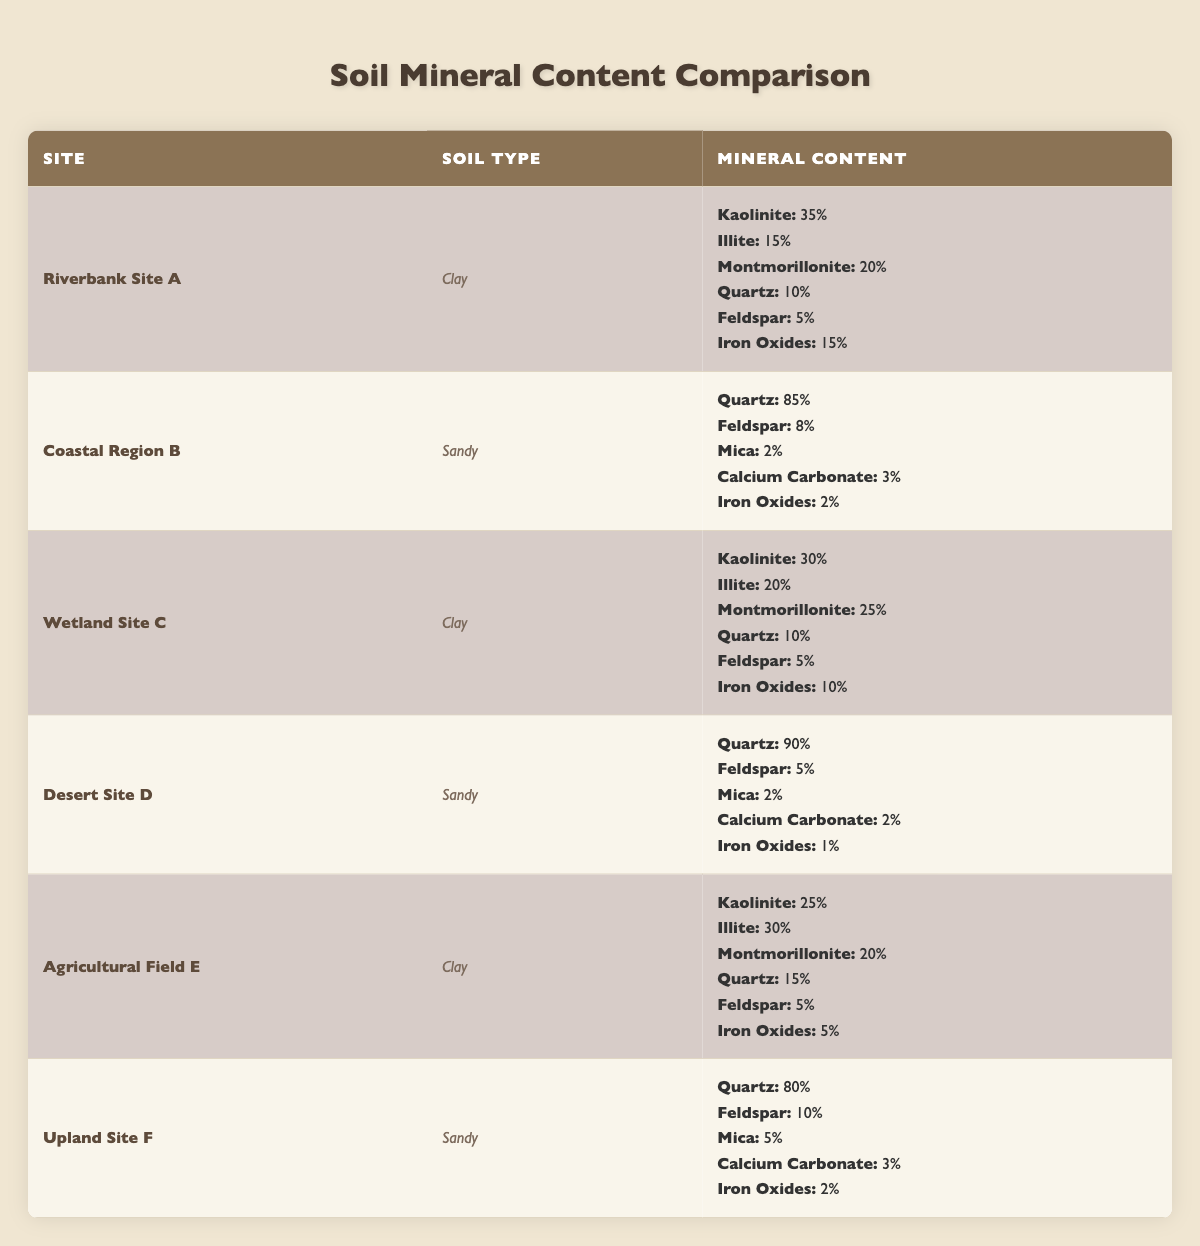What is the mineral content percentage of Kaolinite in Riverbank Site A? The table lists the mineral content for each site. For Riverbank Site A, under the Clay soil type, Kaolinite is specified as 35%.
Answer: 35% Which site has the highest Quartz content? Looking at the table, Desert Site D shows Quartz at 90%, which is higher compared to the other sites listed.
Answer: Desert Site D What mineral has the least percentage in Coastal Region B? In the table, for Coastal Region B, the minerals listed are Quartz (85%), Feldspar (8%), Mica (2%), Calcium Carbonate (3%), and Iron Oxides (2%). The lowest percentage is attributed to Mica and Iron Oxides, both at 2%.
Answer: Mica (or Iron Oxides) What is the total percentage of Iron Oxides in all Sandy soils? To find the total Iron Oxides in Sandy soils, we look at Coastal Region B (2%) + Desert Site D (1%) + Upland Site F (2%) = 2 + 1 + 2 = 5%. The total for Iron Oxides in Sandy soils is therefore 5%.
Answer: 5% Are there any sites where Montmorillonite accounts for over 20%? Upon reviewing the table, Montmorillonite is listed as 20% at Riverbank Site A, 25% at Wetland Site C, and 20% at Agricultural Field E, thus indicating that Wetland Site C is the only site where Montmorillonite exceeds 20%.
Answer: Yes What is the average percentage of Feldspar across all sites? The Feldspar percentages are: Riverbank Site A (5%), Coastal Region B (8%), Wetland Site C (5%), Desert Site D (5%), Agricultural Field E (5%), and Upland Site F (10%). Adding them gives a total of 38%. Dividing by the number of sites (6) results in an average of approximately 6.33%.
Answer: 6.33% Which soil type contains both Illite and Montmorillonite? By examining the table, both Illite and Montmorillonite are found only in Clay soil types. Specifically, they appear in Riverbank Site A (Illite: 15%, Montmorillonite: 20%) and Agricultural Field E (Illite: 30%, Montmorillonite: 20%).
Answer: Clay Is Iron Oxides present in all soils listed? The table shows that Iron Oxides are found in Clay soils at Riverbank Site A (15%), Wetland Site C (10%), and Agricultural Field E (5%). In Sandy soils, it appears in Coastal Region B (2%), Desert Site D (1%), and Upland Site F (2%). Thus, Iron Oxides are indeed present in all soil types listed.
Answer: Yes Which site has a higher percentage of Montmorillonite: Agricultural Field E or Wetland Site C? The table indicates that Agricultural Field E has 20% Montmorillonite, whereas Wetland Site C has 25%. Comparing these values, Wetland Site C exceeds Agricultural Field E.
Answer: Wetland Site C 